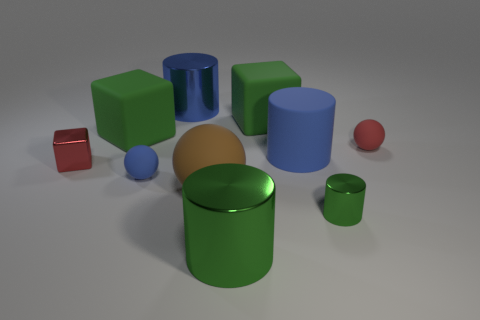What number of tiny green metallic objects are behind the brown thing?
Your answer should be compact. 0. How many spheres are red rubber things or large shiny things?
Your answer should be compact. 1. There is a block that is left of the brown sphere and behind the tiny block; what is its size?
Your answer should be compact. Large. How many other things are the same color as the small shiny cylinder?
Offer a very short reply. 3. Is the material of the tiny blue sphere the same as the big blue thing that is behind the small red rubber thing?
Your answer should be compact. No. How many things are large metallic cylinders that are in front of the small metallic block or cyan metallic objects?
Your answer should be very brief. 1. The shiny thing that is both on the right side of the blue matte ball and behind the small blue rubber object has what shape?
Give a very brief answer. Cylinder. Is there anything else that has the same size as the red cube?
Ensure brevity in your answer.  Yes. What size is the blue cylinder that is the same material as the large brown thing?
Your answer should be very brief. Large. What number of objects are red things that are to the right of the blue rubber cylinder or large green shiny cylinders in front of the small red rubber ball?
Ensure brevity in your answer.  2. 